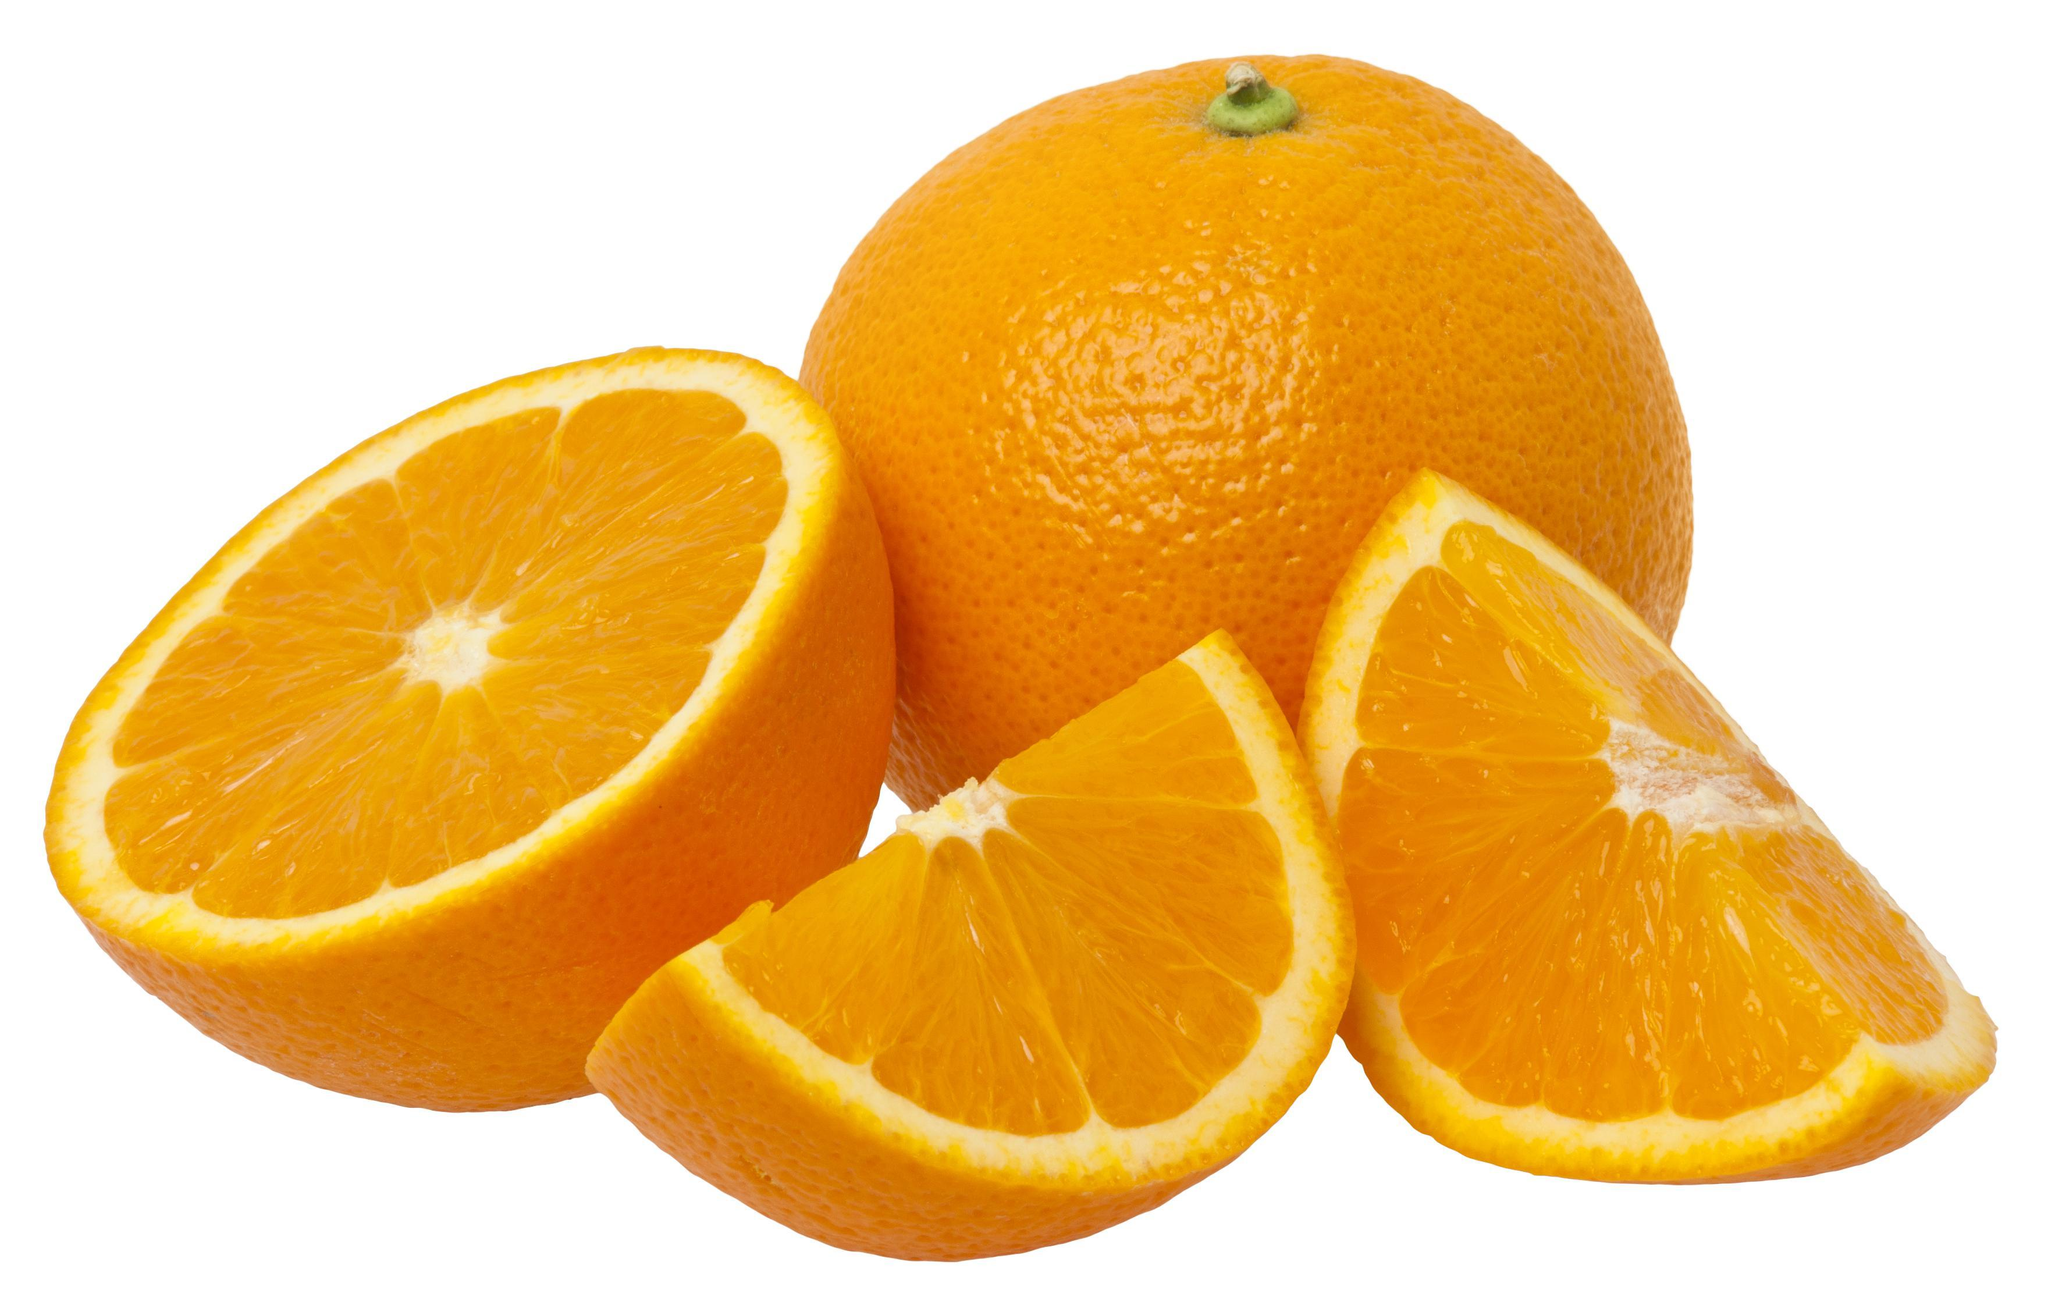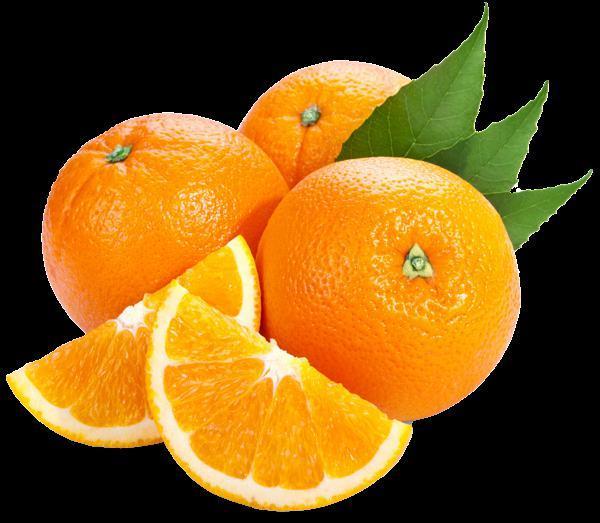The first image is the image on the left, the second image is the image on the right. For the images shown, is this caption "In at least one image there are three parallel orange leaves next to no more then three full oranges." true? Answer yes or no. Yes. 